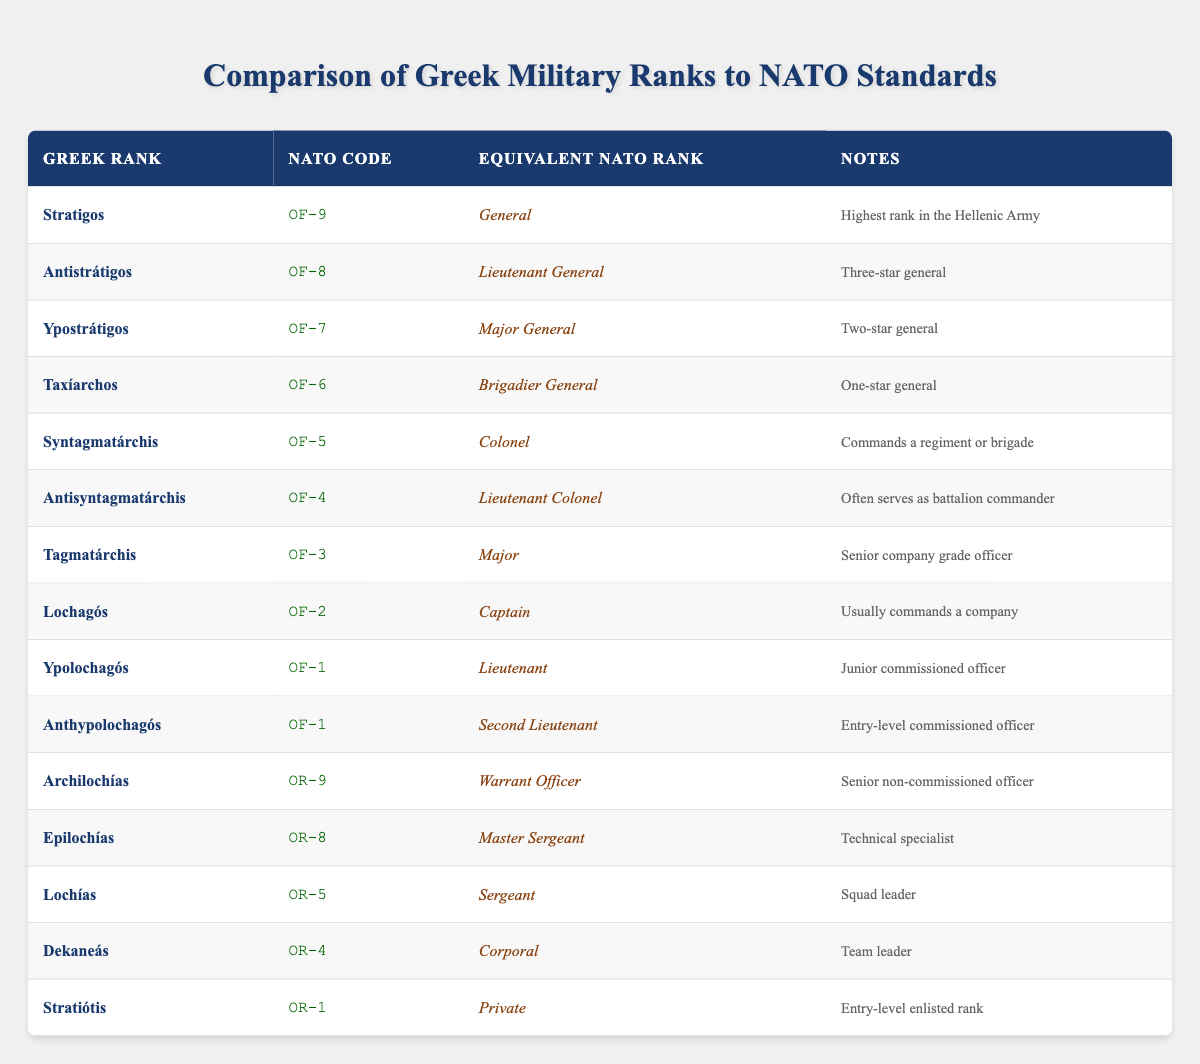What is the NATO code for the Greek rank 'Ypostrátigos'? The NATO code for 'Ypostrátigos' can be found in the second column of the corresponding row. Looking at the row for 'Ypostrátigos', the NATO code listed is OF-7.
Answer: OF-7 How many ranks have the equivalent NATO rank of General? To determine the number of ranks equivalent to General, we need to scan the 'Equivalent NATO Rank' column for the term 'General'. There are three entries: 'Stratigos' (General), 'Antistrátigos' (Lieutenant General), and 'Ypostrátigos' (Major General). Thus, there is 1 rank exactly equivalent to General, which is 'Stratigos'.
Answer: 1 Is 'Lochías' a non-commissioned officer rank? The rank 'Lochías' is found in the table, and by looking at the 'NATO Code' column which starts with "OR", we can determine it is a non-commissioned officer rank. Hence, the answer is true.
Answer: Yes What is the equivalent NATO rank for 'Taxíarchos'? Looking at the row for 'Taxíarchos', the 'Equivalent NATO Rank' column indicates it is equivalent to 'Brigadier General'.
Answer: Brigadier General Which Greek rank has the same NATO code as 'Ypolochagós'? The NATO code for 'Ypolochagós' is OF-1, and when filtering for this code in the 'NATO Code' column, we find that 'Anthypolochagós' also has the same NATO code of OF-1.
Answer: Anthypolochagós How many ranks have a NATO code higher than OF-5? To find the total number of ranks with a NATO code higher than OF-5, we look at the NATO codes listed. The ranks above OF-5 are 'OF-6' (Taxíarchos), 'OF-7' (Ypostrátigos), 'OF-8' (Antistrátigos), and 'OF-9' (Stratigos), resulting in four ranks.
Answer: 4 Is 'Dekaneás' in the commissioned officer category? By looking up 'Dekaneás' in the table, we find its class under the NATO coding system is indicated with "OR", which means it is a non-commissioned officer rank. Therefore, it is false that 'Dekaneás' is a commissioned officer.
Answer: No What is the highest Greek military rank according to this table? The highest Greek military rank can be found by looking at the first entry in the table, which lists 'Stratigos' as corresponding to NATO code OF-9 and identified as the highest rank in the Hellenic Army.
Answer: Stratigos 